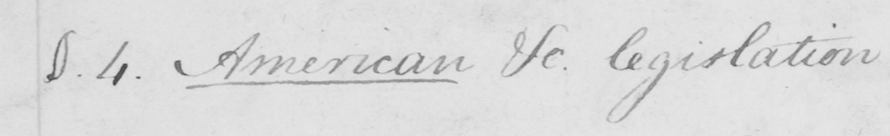What does this handwritten line say? §.4 . American etc . legislation 